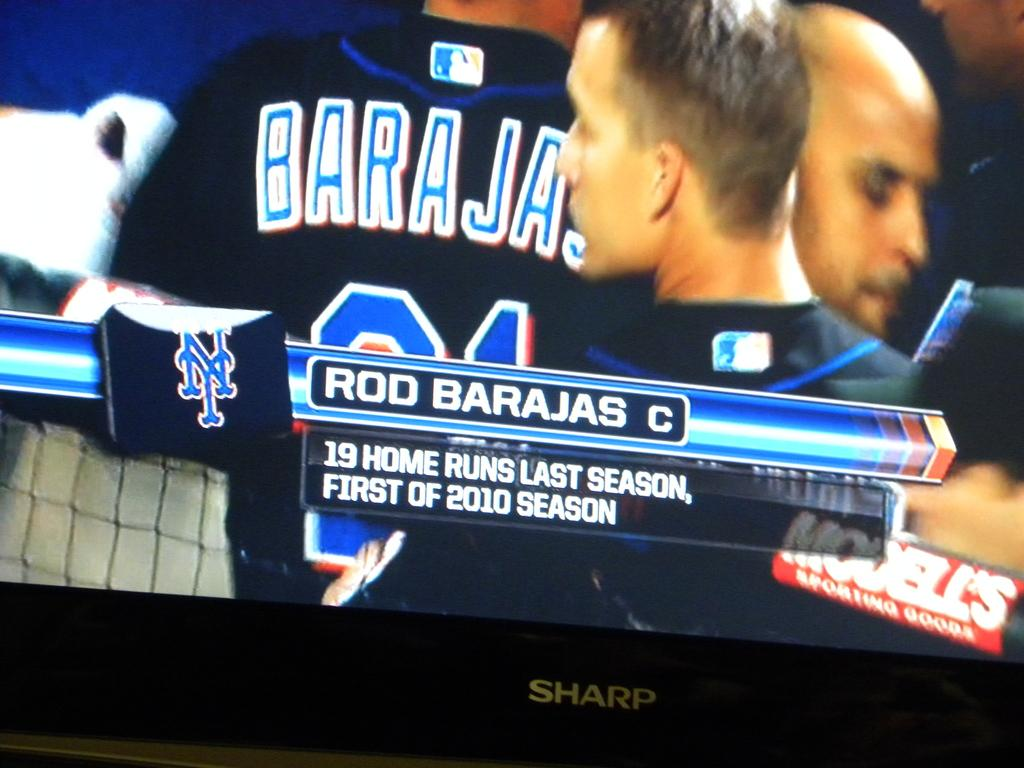<image>
Relay a brief, clear account of the picture shown. Rod Barajas who is the catcher of the New York Mets 